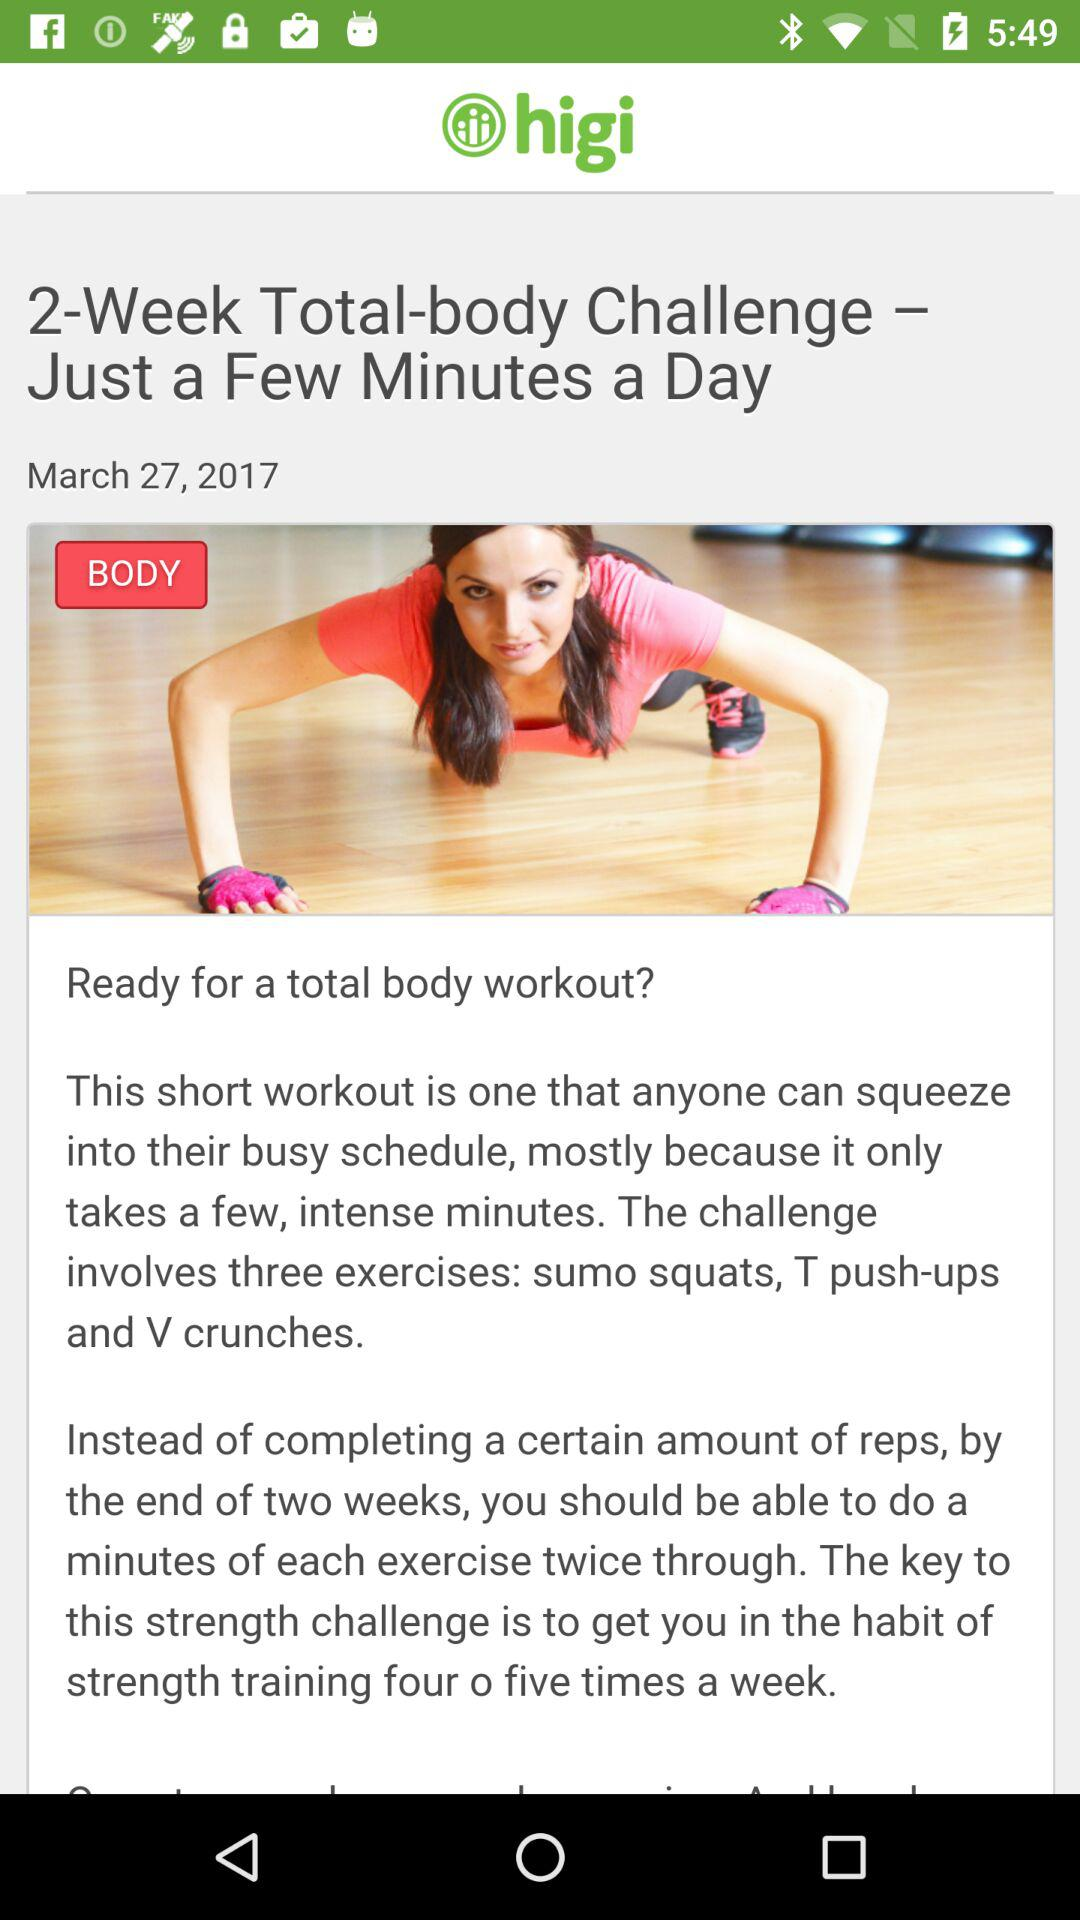How many exercises are involved in the challenge?
Answer the question using a single word or phrase. 3 